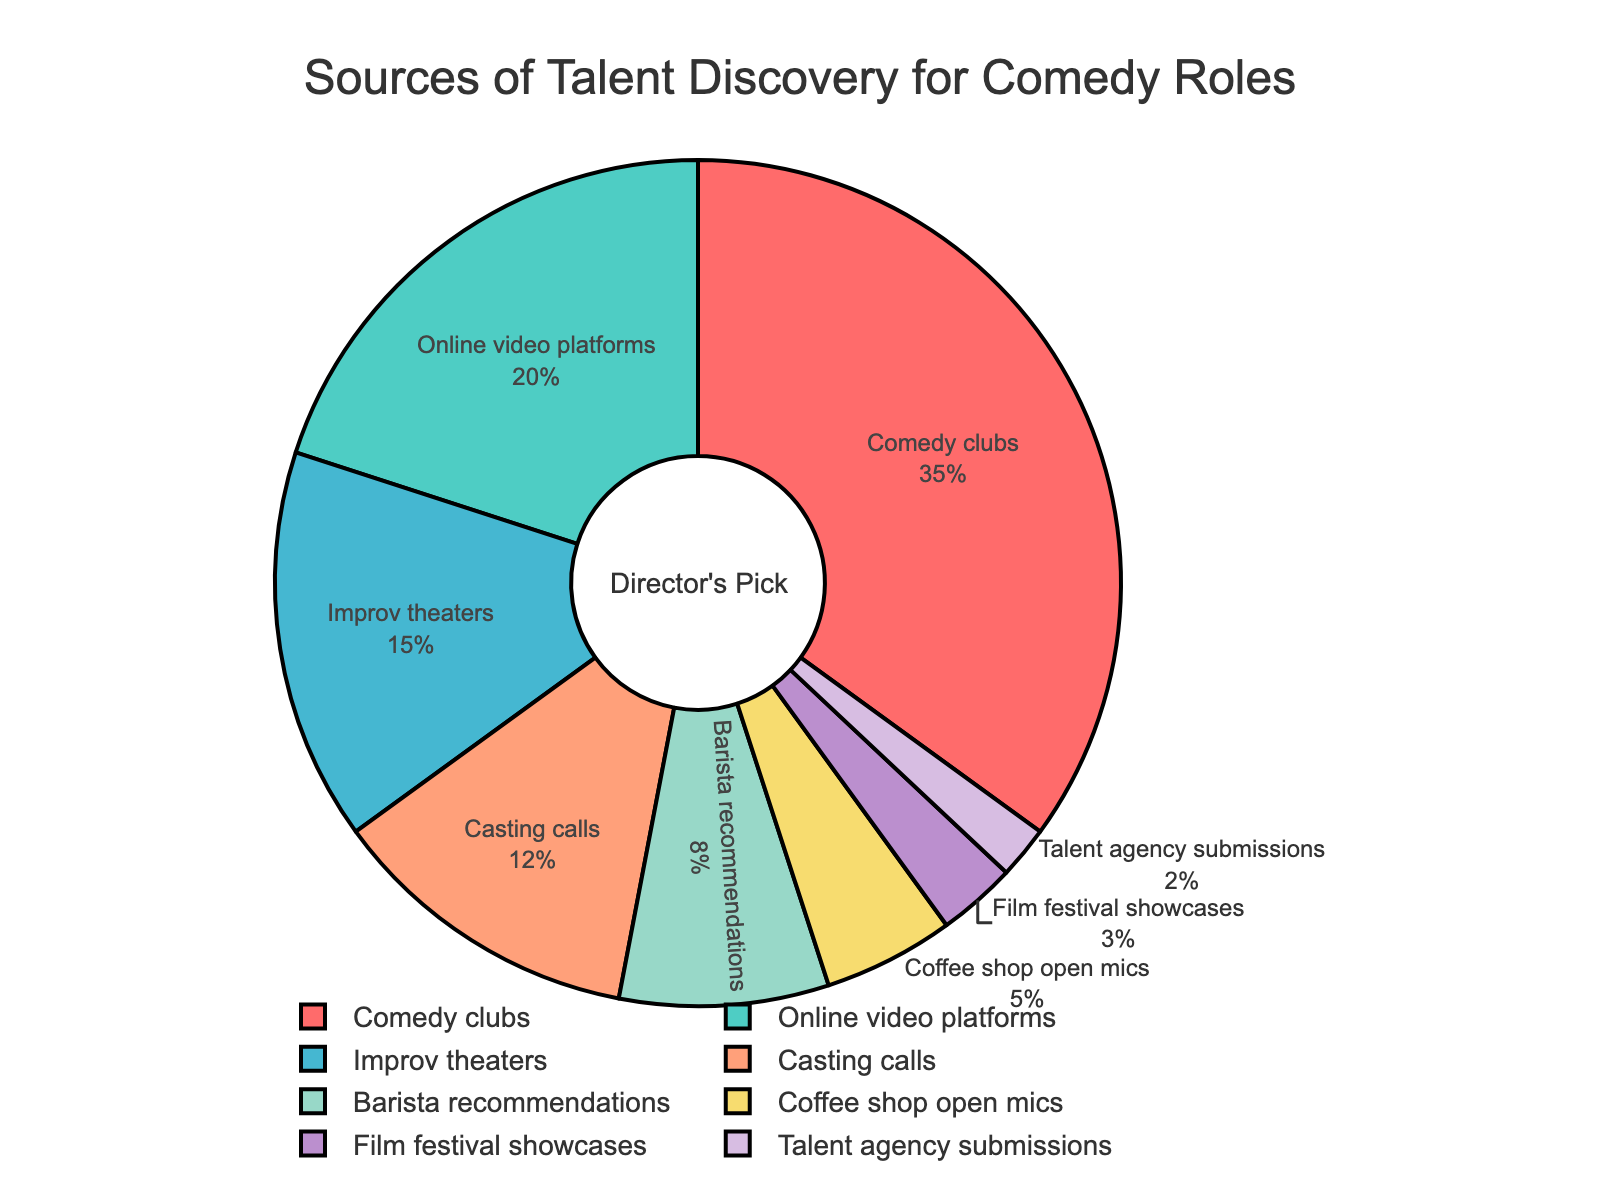What is the most significant source of talent discovery for comedy roles? The most significant source of talent discovery can be identified by looking at the largest section of the pie chart, which is labeled "Comedy clubs" and takes up 35% of the pie.
Answer: Comedy clubs How does the percentage of talent discovered through improv theaters compare to that through online video platforms? To compare these percentages, observe their corresponding sections in the pie chart. Improv theaters account for 15% while online video platforms represent 20%.
Answer: Improv theaters: 15%, Online video platforms: 20% Which source has a smaller percentage of discovery, coffee shop open mics or barista recommendations? By visually comparing the two sections, coffee shop open mics account for 5% and barista recommendations for 8%. Hence, coffee shop open mics have a smaller percentage.
Answer: Coffee shop open mics What is the combined percentage for talent discovered via casting calls and film festival showcases? Sum the percentages of the two sources: casting calls (12%) and film festival showcases (3%). Therefore, the combined percentage is 12% + 3% = 15%.
Answer: 15% Which source comprises the smallest slice of the pie chart? The smallest slice is labeled "Talent agency submissions" and represents 2% of the pie chart.
Answer: Talent agency submissions How much more significant is the contribution from comedy clubs compared to barista recommendations? Subtract the barista recommendations percentage (8%) from the comedy clubs percentage (35%): 35% - 8% = 27%.
Answer: 27% What percentage of talent is discovered through sources other than comedy clubs and online video platforms? To find this, subtract the percentages of comedy clubs (35%) and online video platforms (20%) from 100%: 100% - 35% - 20% = 45%.
Answer: 45% If one were to combine the percentages of talent discovered through comedy clubs, improv theaters, and casting calls, what would be the total? Sum the percentages of comedy clubs (35%), improv theaters (15%), and casting calls (12%): 35% + 15% + 12% = 62%.
Answer: 62% What visual element indicates the percentage of talent discovered through improv theaters? The segment representing improv theaters is colored accordingly and is marked on the chart with a label showing its percentage, which is 15%.
Answer: Colored segment with 15% label Is the percentage of talent discovered through coffee shop open mics more or less than a third of that discovered through comedy clubs? A third of the comedy clubs percentage is 35% / 3 ≈ 11.67%. Coffee shop open mics account for 5%, which is less than 11.67%.
Answer: Less 